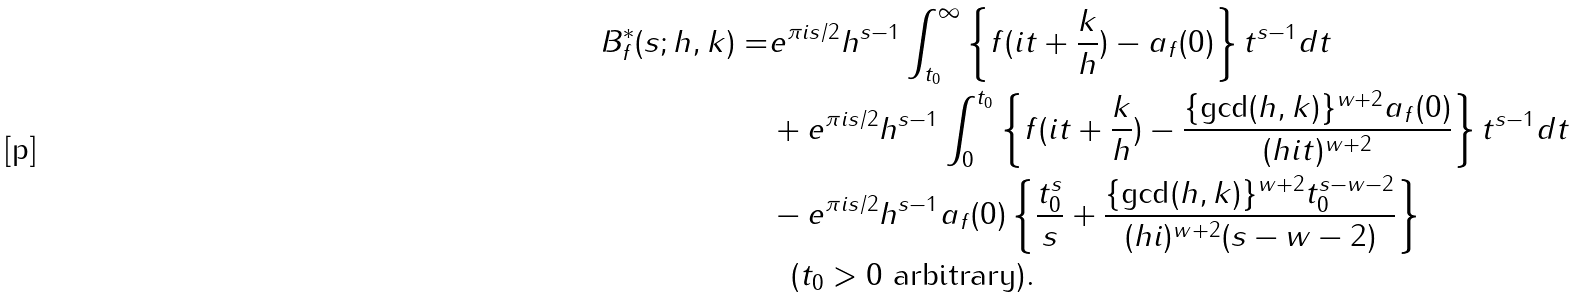Convert formula to latex. <formula><loc_0><loc_0><loc_500><loc_500>B _ { f } ^ { * } ( s ; h , k ) = & e ^ { \pi i s / 2 } h ^ { s - 1 } \int _ { t _ { 0 } } ^ { \infty } \left \{ f ( i t + \frac { k } { h } ) - a _ { f } ( 0 ) \right \} t ^ { s - 1 } d t \\ & + e ^ { \pi i s / 2 } h ^ { s - 1 } \int _ { 0 } ^ { t _ { 0 } } \left \{ f ( i t + \frac { k } { h } ) - \frac { \{ \gcd ( h , k ) \} ^ { w + 2 } a _ { f } ( 0 ) } { ( h i t ) ^ { w + 2 } } \right \} t ^ { s - 1 } d t \\ & - e ^ { \pi i s / 2 } h ^ { s - 1 } a _ { f } ( 0 ) \left \{ \frac { t _ { 0 } ^ { s } } { s } + \frac { \{ \gcd ( h , k ) \} ^ { w + 2 } t _ { 0 } ^ { s - w - 2 } } { ( h i ) ^ { w + 2 } ( s - w - 2 ) } \right \} \\ & \ \ ( t _ { 0 } > 0 \text { arbitrary} ) .</formula> 